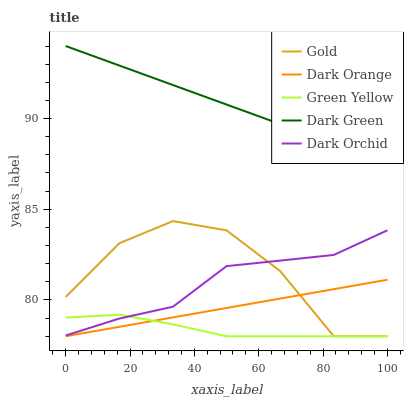Does Green Yellow have the minimum area under the curve?
Answer yes or no. Yes. Does Dark Green have the maximum area under the curve?
Answer yes or no. Yes. Does Dark Orchid have the minimum area under the curve?
Answer yes or no. No. Does Dark Orchid have the maximum area under the curve?
Answer yes or no. No. Is Dark Green the smoothest?
Answer yes or no. Yes. Is Gold the roughest?
Answer yes or no. Yes. Is Green Yellow the smoothest?
Answer yes or no. No. Is Green Yellow the roughest?
Answer yes or no. No. Does Dark Orchid have the lowest value?
Answer yes or no. No. Does Dark Orchid have the highest value?
Answer yes or no. No. Is Dark Orange less than Dark Green?
Answer yes or no. Yes. Is Dark Green greater than Gold?
Answer yes or no. Yes. Does Dark Orange intersect Dark Green?
Answer yes or no. No. 